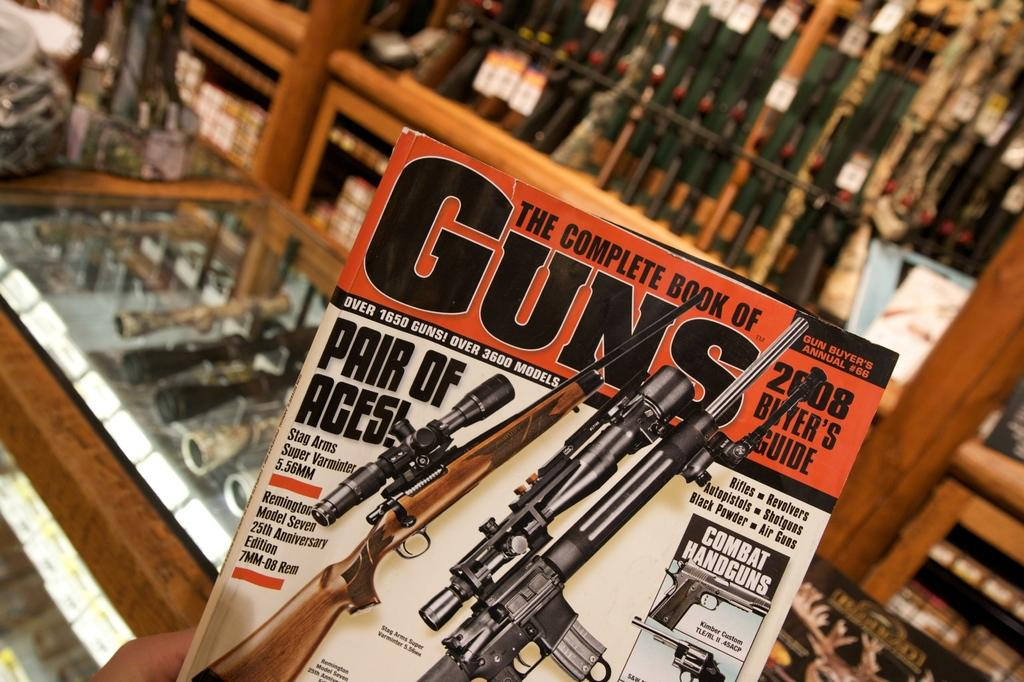<image>
Render a clear and concise summary of the photo. A magazine of The Complete Book of Guns. 